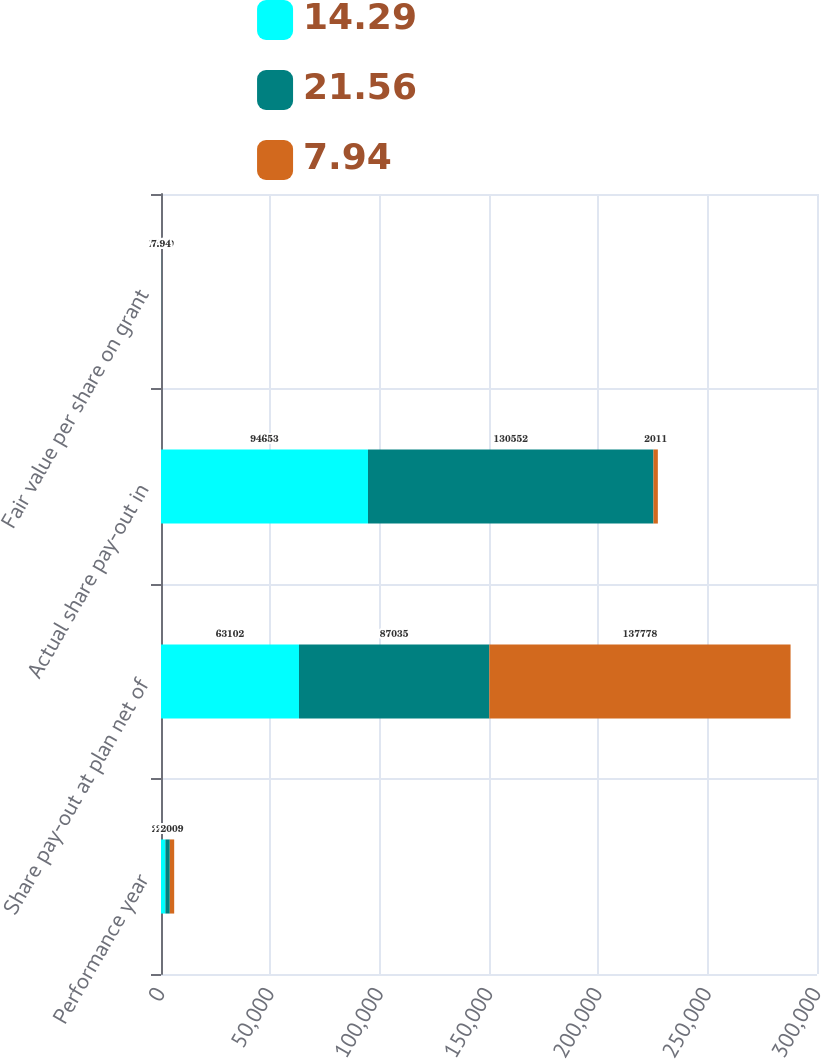<chart> <loc_0><loc_0><loc_500><loc_500><stacked_bar_chart><ecel><fcel>Performance year<fcel>Share pay-out at plan net of<fcel>Actual share pay-out in<fcel>Fair value per share on grant<nl><fcel>14.29<fcel>2011<fcel>63102<fcel>94653<fcel>21.56<nl><fcel>21.56<fcel>2010<fcel>87035<fcel>130552<fcel>14.29<nl><fcel>7.94<fcel>2009<fcel>137778<fcel>2011<fcel>7.94<nl></chart> 